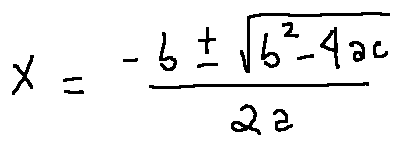Convert formula to latex. <formula><loc_0><loc_0><loc_500><loc_500>x = \frac { - b \pm \sqrt { b ^ { 2 } - 4 a c } } { 2 a }</formula> 